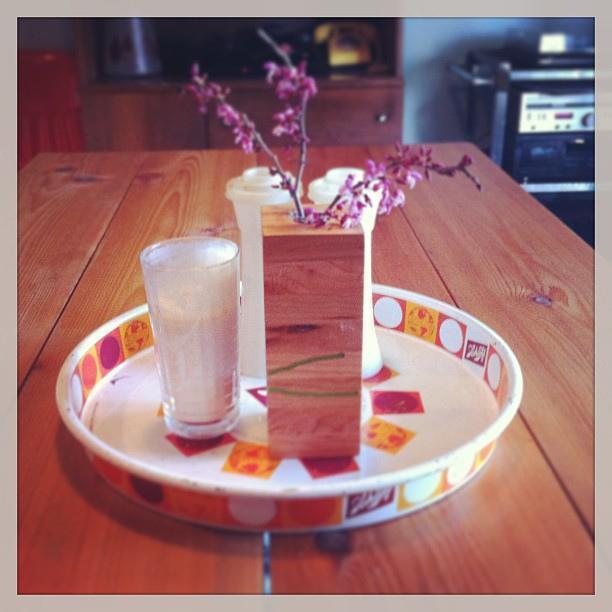How many dining tables are visible?
Give a very brief answer. 1. How many potted plants can you see?
Give a very brief answer. 1. How many people are skiing?
Give a very brief answer. 0. 